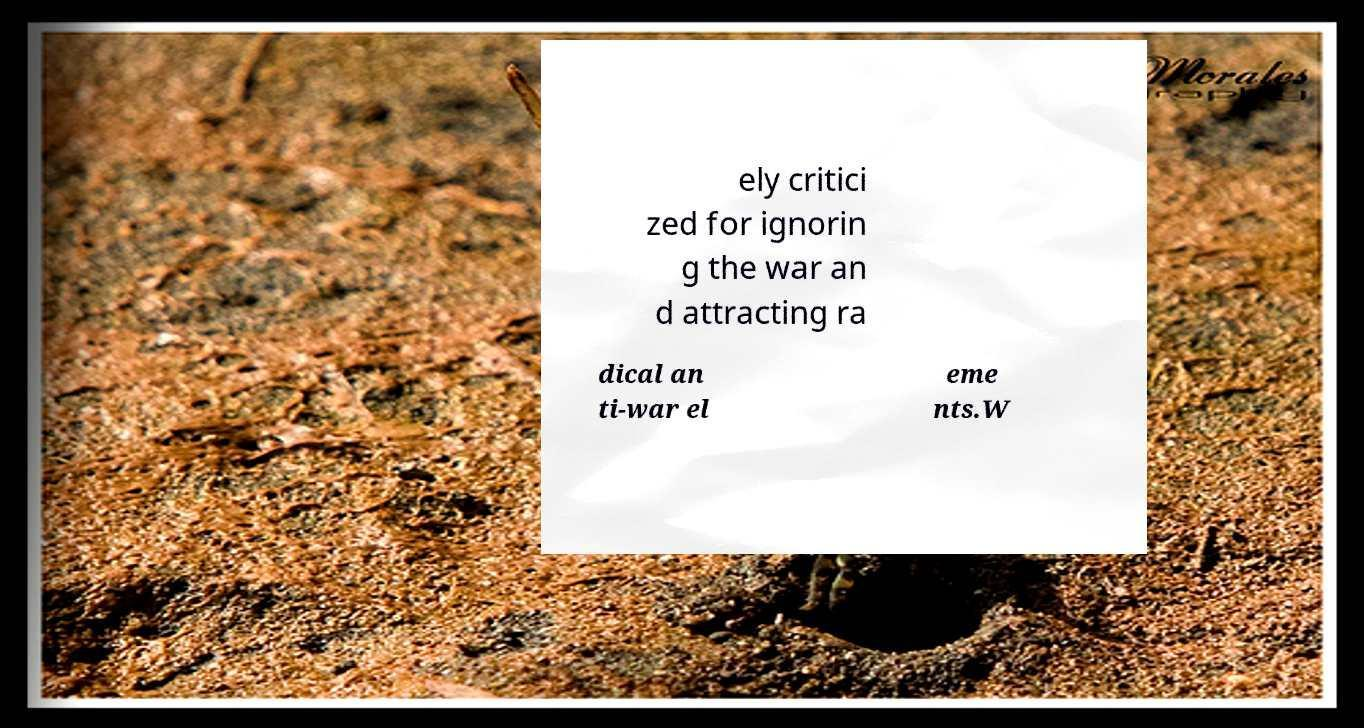I need the written content from this picture converted into text. Can you do that? ely critici zed for ignorin g the war an d attracting ra dical an ti-war el eme nts.W 